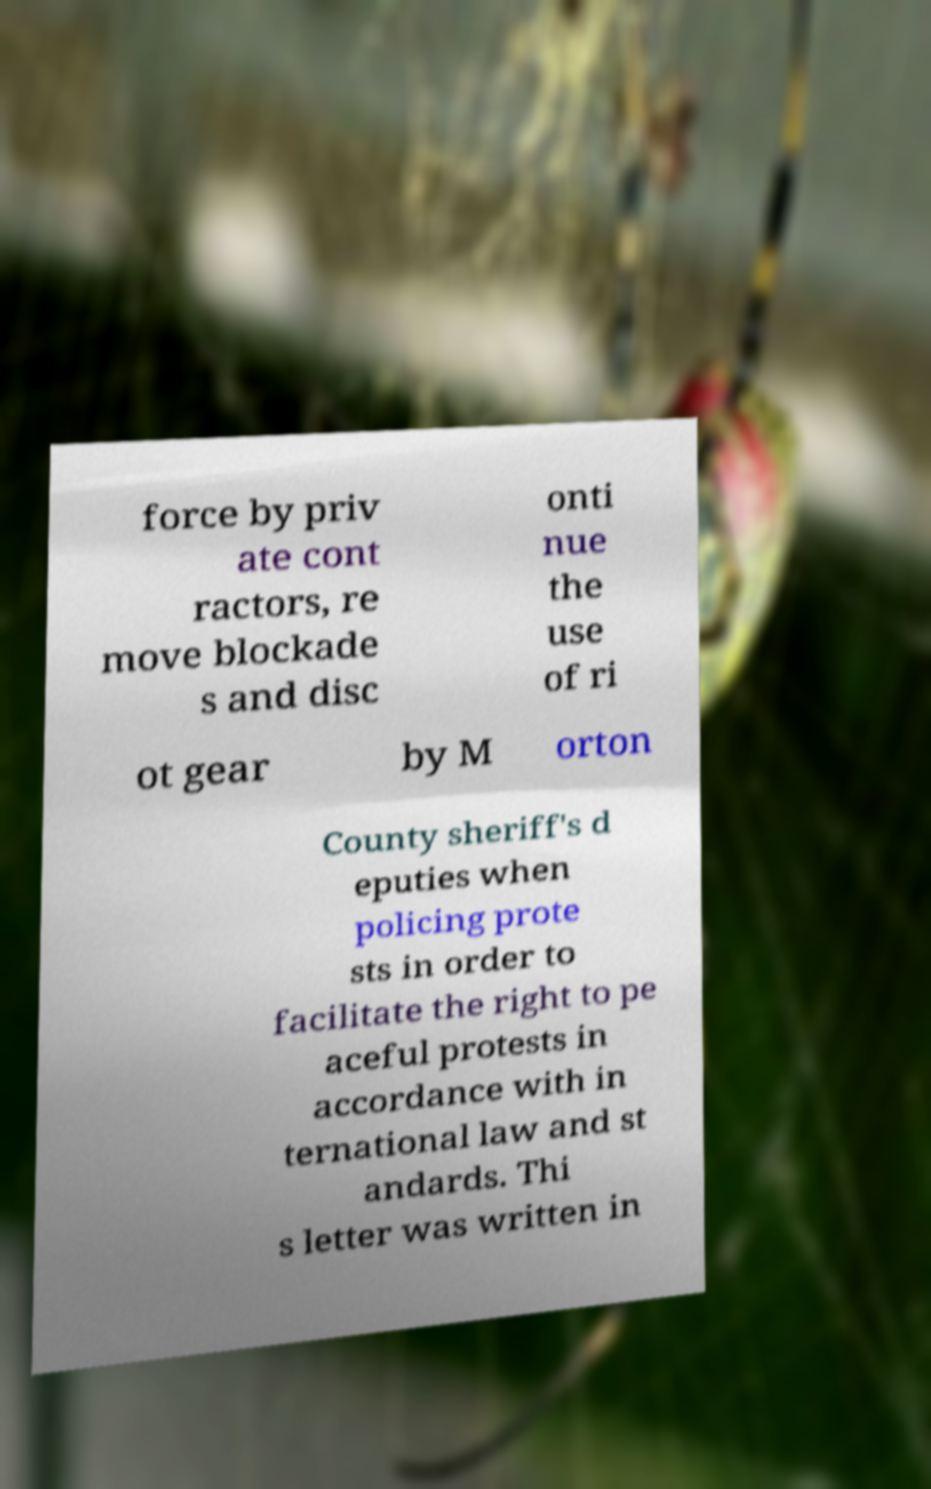For documentation purposes, I need the text within this image transcribed. Could you provide that? force by priv ate cont ractors, re move blockade s and disc onti nue the use of ri ot gear by M orton County sheriff's d eputies when policing prote sts in order to facilitate the right to pe aceful protests in accordance with in ternational law and st andards. Thi s letter was written in 